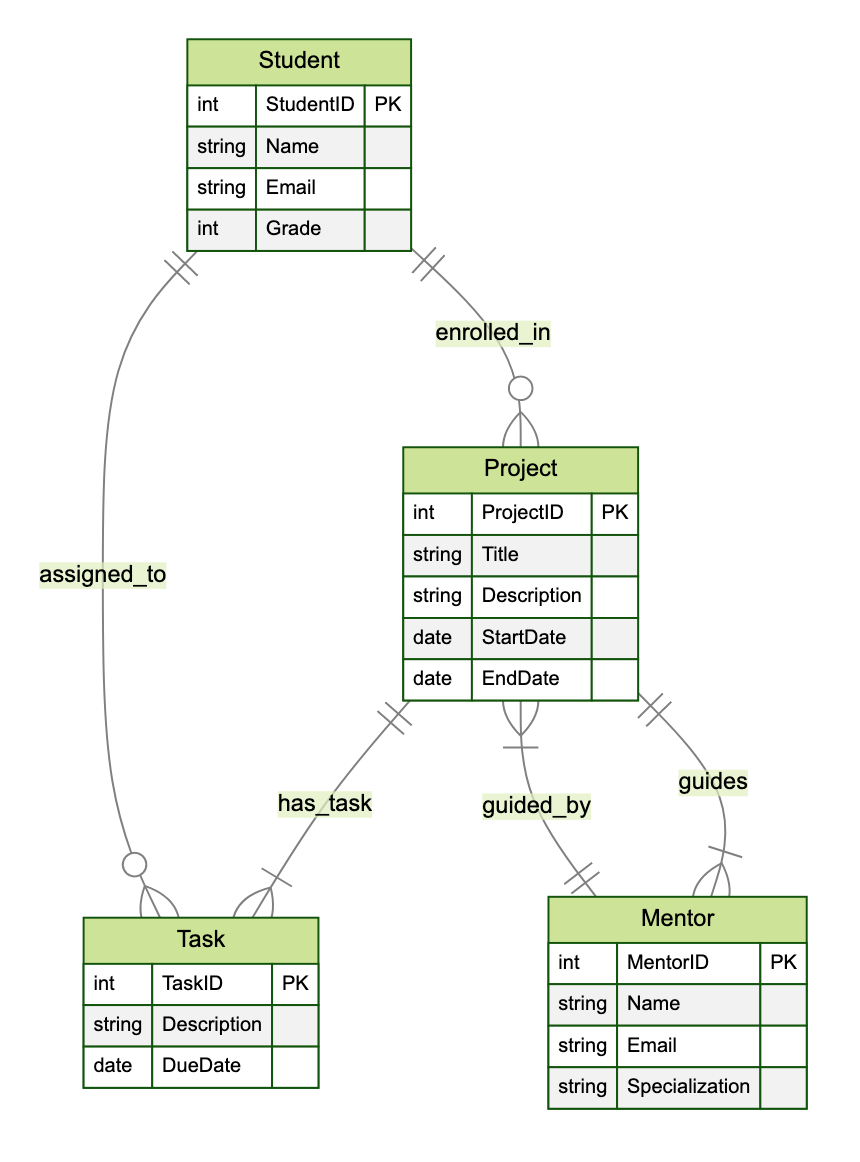What entities are present in the diagram? The diagram consists of four entities: Student, Project, Task, and Mentor. Each of these entities has its attributes defined.
Answer: Student, Project, Task, Mentor How many attributes does the Project entity have? The Project entity has four attributes: ProjectID, Title, Description, StartDate, and EndDate, making a total of five.
Answer: five What is the relationship between Student and Task? The relationship between Student and Task is many to many, indicating that multiple students can be assigned to multiple tasks.
Answer: many to many How many tasks can a Project have? A Project can have one or many tasks as indicated by the one to many relationship between Project and Task.
Answer: one to many Which entity guides the Project? The entity that guides the Project is Mentor, showcasing the role of Mentors in overseeing Projects.
Answer: Mentor How many relationships does the Student entity have? The Student entity has two relationships: enrolled_in with Project and assigned_to with Task, making a total of two relationships.
Answer: two Can a Mentor guide multiple Projects? Yes, a Mentor can guide multiple Projects, as indicated by the many to many relationship between Mentor and Project.
Answer: yes What is the main function of the Task entity? The main function of the Task entity is to indicate specific tasks that are assigned to students and belong to a project.
Answer: assign tasks What attribute defines the specialization of a Mentor? The specialization of a Mentor is defined by the attribute called Specialization within the Mentor entity.
Answer: Specialization How does the Task relate to its parent Project? The Task relates to its parent Project through the belongs_to relationship, indicating it is associated with one specific project.
Answer: belongs_to 